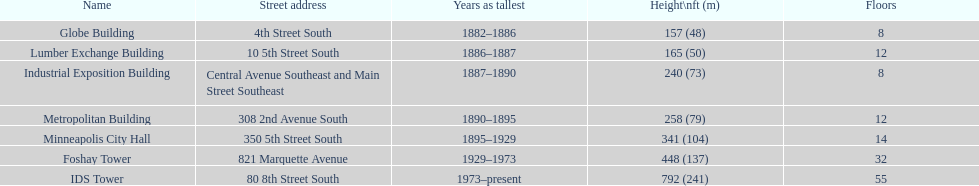Is the metropolitan building or the lumber exchange building taller? Metropolitan Building. 